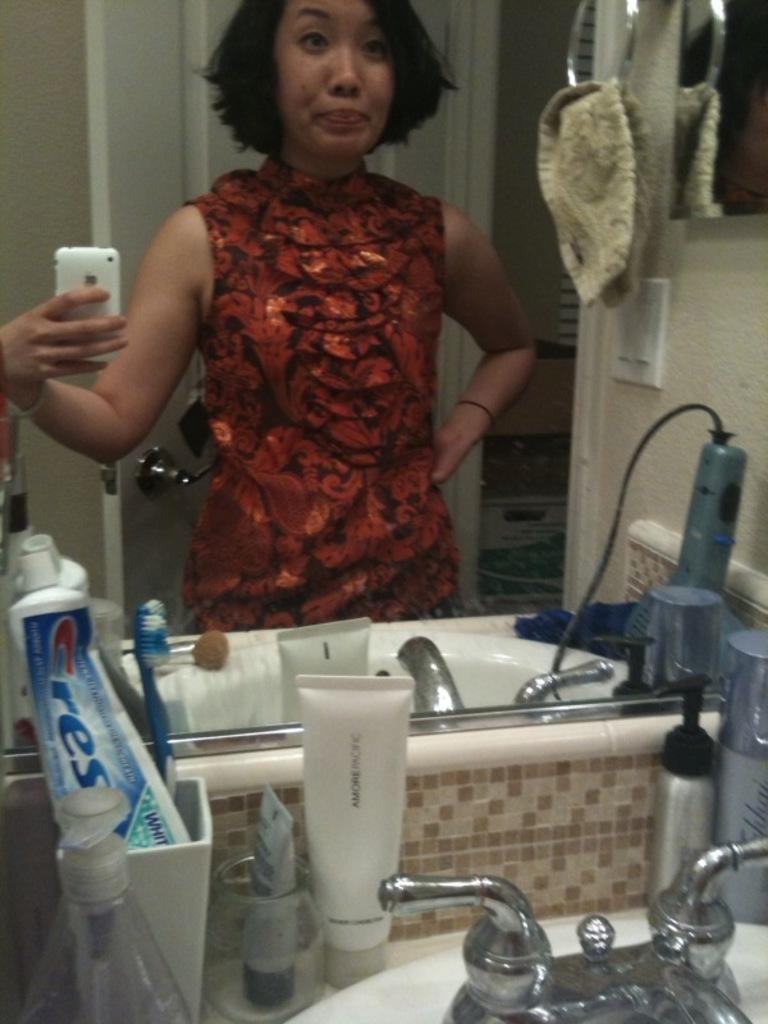<image>
Provide a brief description of the given image. A woman takes a selfie in a bathroom mirror and her Crest toothpaste is visible. 